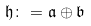Convert formula to latex. <formula><loc_0><loc_0><loc_500><loc_500>\mathfrak { h } \colon = \mathfrak { a } \oplus \mathfrak { b }</formula> 